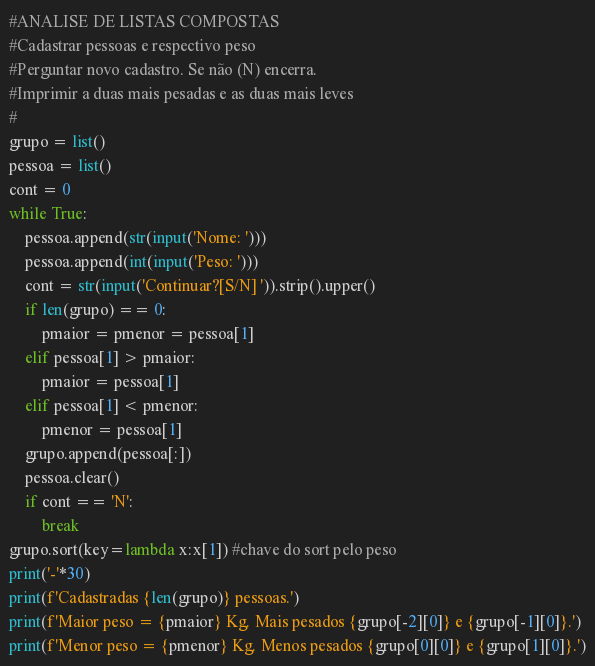Convert code to text. <code><loc_0><loc_0><loc_500><loc_500><_Python_>#ANALISE DE LISTAS COMPOSTAS
#Cadastrar pessoas e respectivo peso
#Perguntar novo cadastro. Se não (N) encerra.
#Imprimir a duas mais pesadas e as duas mais leves
#
grupo = list()
pessoa = list()
cont = 0
while True:
    pessoa.append(str(input('Nome: ')))
    pessoa.append(int(input('Peso: ')))
    cont = str(input('Continuar?[S/N] ')).strip().upper()
    if len(grupo) == 0:
        pmaior = pmenor = pessoa[1]
    elif pessoa[1] > pmaior:
        pmaior = pessoa[1]
    elif pessoa[1] < pmenor:
        pmenor = pessoa[1]
    grupo.append(pessoa[:])
    pessoa.clear()
    if cont == 'N':
        break
grupo.sort(key=lambda x:x[1]) #chave do sort pelo peso
print('-'*30)
print(f'Cadastradas {len(grupo)} pessoas.')
print(f'Maior peso = {pmaior} Kg. Mais pesados {grupo[-2][0]} e {grupo[-1][0]}.')
print(f'Menor peso = {pmenor} Kg. Menos pesados {grupo[0][0]} e {grupo[1][0]}.')</code> 